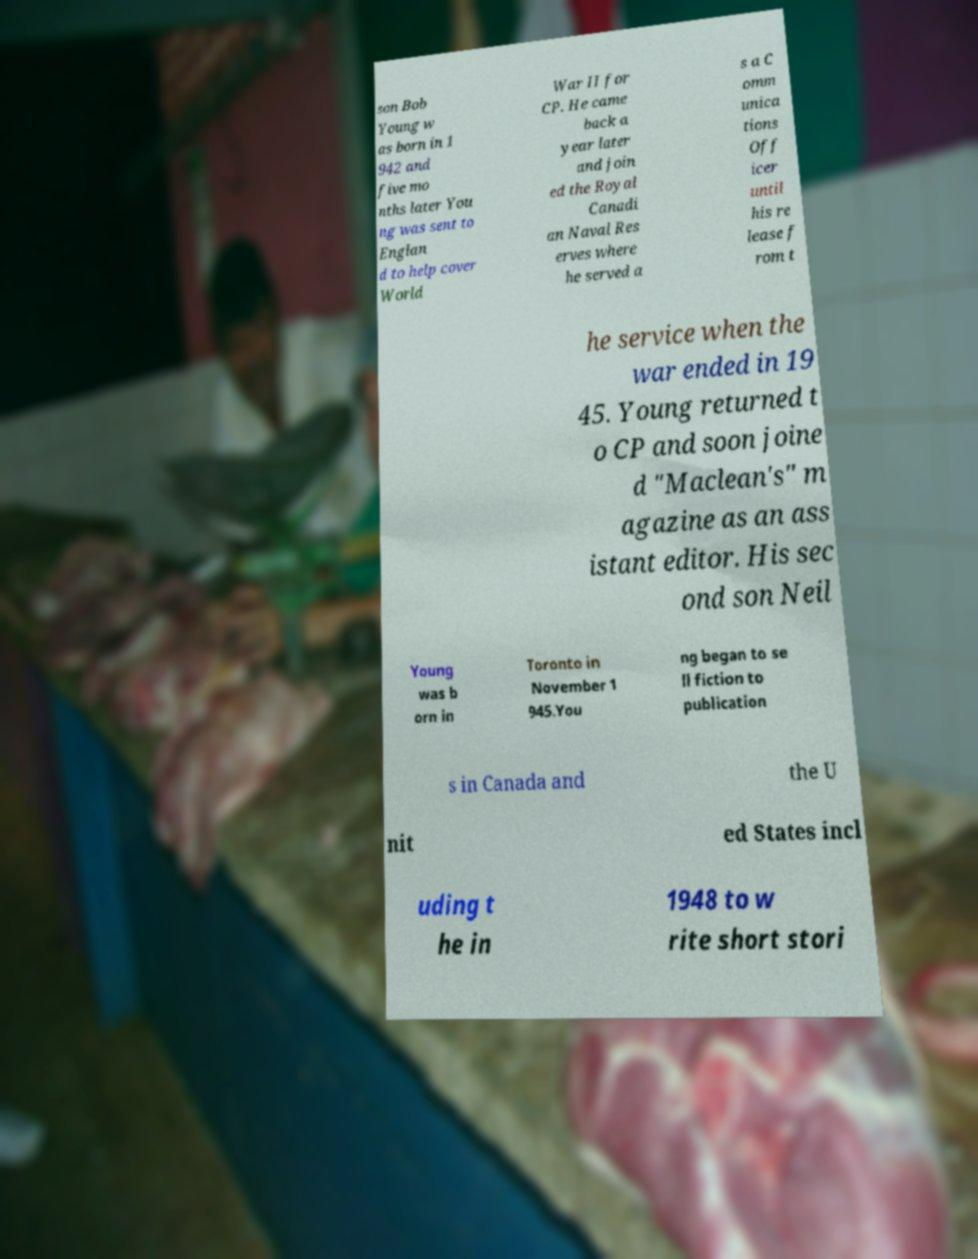Please read and relay the text visible in this image. What does it say? son Bob Young w as born in 1 942 and five mo nths later You ng was sent to Englan d to help cover World War II for CP. He came back a year later and join ed the Royal Canadi an Naval Res erves where he served a s a C omm unica tions Off icer until his re lease f rom t he service when the war ended in 19 45. Young returned t o CP and soon joine d "Maclean's" m agazine as an ass istant editor. His sec ond son Neil Young was b orn in Toronto in November 1 945.You ng began to se ll fiction to publication s in Canada and the U nit ed States incl uding t he in 1948 to w rite short stori 